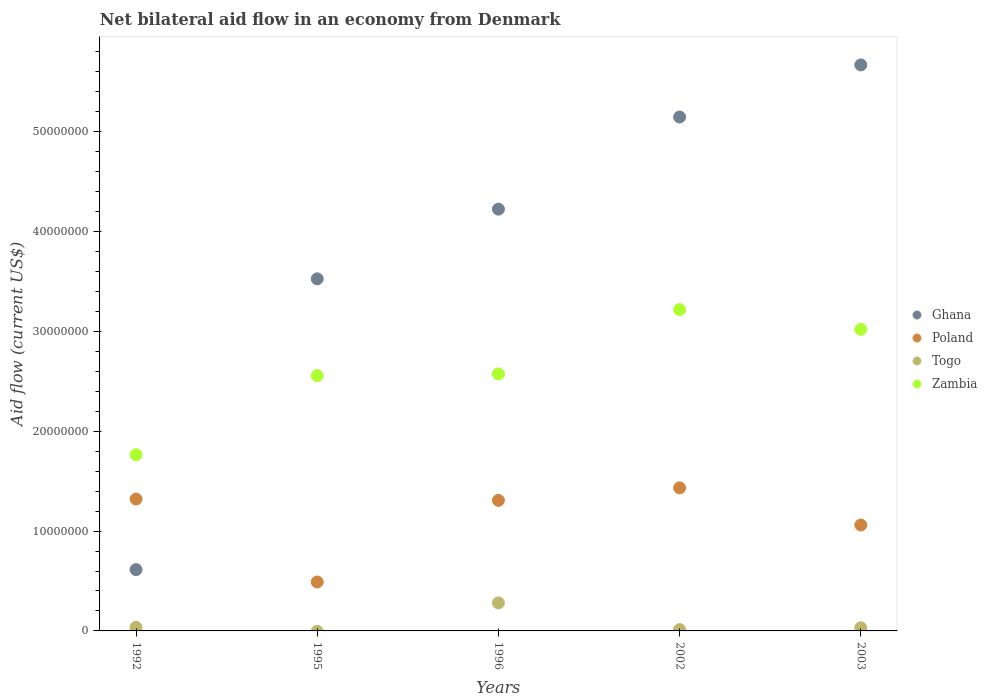What is the net bilateral aid flow in Poland in 2002?
Your answer should be very brief. 1.43e+07. Across all years, what is the maximum net bilateral aid flow in Ghana?
Offer a very short reply. 5.67e+07. Across all years, what is the minimum net bilateral aid flow in Ghana?
Your answer should be compact. 6.14e+06. In which year was the net bilateral aid flow in Zambia maximum?
Ensure brevity in your answer.  2002. What is the total net bilateral aid flow in Togo in the graph?
Offer a terse response. 3.62e+06. What is the difference between the net bilateral aid flow in Poland in 1995 and that in 2002?
Give a very brief answer. -9.43e+06. What is the difference between the net bilateral aid flow in Zambia in 2003 and the net bilateral aid flow in Poland in 1995?
Provide a short and direct response. 2.53e+07. What is the average net bilateral aid flow in Zambia per year?
Offer a terse response. 2.63e+07. In the year 1996, what is the difference between the net bilateral aid flow in Ghana and net bilateral aid flow in Togo?
Your answer should be very brief. 3.94e+07. In how many years, is the net bilateral aid flow in Zambia greater than 40000000 US$?
Make the answer very short. 0. What is the ratio of the net bilateral aid flow in Zambia in 2002 to that in 2003?
Give a very brief answer. 1.07. Is the difference between the net bilateral aid flow in Ghana in 2002 and 2003 greater than the difference between the net bilateral aid flow in Togo in 2002 and 2003?
Keep it short and to the point. No. What is the difference between the highest and the second highest net bilateral aid flow in Ghana?
Your answer should be very brief. 5.22e+06. What is the difference between the highest and the lowest net bilateral aid flow in Togo?
Make the answer very short. 2.81e+06. In how many years, is the net bilateral aid flow in Ghana greater than the average net bilateral aid flow in Ghana taken over all years?
Offer a terse response. 3. Is the sum of the net bilateral aid flow in Poland in 1995 and 2002 greater than the maximum net bilateral aid flow in Togo across all years?
Offer a very short reply. Yes. Is it the case that in every year, the sum of the net bilateral aid flow in Zambia and net bilateral aid flow in Ghana  is greater than the sum of net bilateral aid flow in Togo and net bilateral aid flow in Poland?
Keep it short and to the point. Yes. Is it the case that in every year, the sum of the net bilateral aid flow in Togo and net bilateral aid flow in Poland  is greater than the net bilateral aid flow in Zambia?
Offer a terse response. No. Is the net bilateral aid flow in Togo strictly greater than the net bilateral aid flow in Zambia over the years?
Provide a short and direct response. No. How many dotlines are there?
Your answer should be compact. 4. Are the values on the major ticks of Y-axis written in scientific E-notation?
Ensure brevity in your answer.  No. Does the graph contain any zero values?
Keep it short and to the point. Yes. Where does the legend appear in the graph?
Your answer should be compact. Center right. What is the title of the graph?
Offer a terse response. Net bilateral aid flow in an economy from Denmark. What is the label or title of the X-axis?
Your answer should be compact. Years. What is the Aid flow (current US$) of Ghana in 1992?
Your response must be concise. 6.14e+06. What is the Aid flow (current US$) of Poland in 1992?
Your answer should be very brief. 1.32e+07. What is the Aid flow (current US$) in Zambia in 1992?
Make the answer very short. 1.76e+07. What is the Aid flow (current US$) in Ghana in 1995?
Provide a short and direct response. 3.53e+07. What is the Aid flow (current US$) in Poland in 1995?
Ensure brevity in your answer.  4.90e+06. What is the Aid flow (current US$) in Zambia in 1995?
Provide a succinct answer. 2.56e+07. What is the Aid flow (current US$) of Ghana in 1996?
Give a very brief answer. 4.22e+07. What is the Aid flow (current US$) of Poland in 1996?
Ensure brevity in your answer.  1.31e+07. What is the Aid flow (current US$) of Togo in 1996?
Your answer should be very brief. 2.81e+06. What is the Aid flow (current US$) of Zambia in 1996?
Make the answer very short. 2.58e+07. What is the Aid flow (current US$) in Ghana in 2002?
Ensure brevity in your answer.  5.15e+07. What is the Aid flow (current US$) of Poland in 2002?
Offer a terse response. 1.43e+07. What is the Aid flow (current US$) of Togo in 2002?
Offer a terse response. 1.30e+05. What is the Aid flow (current US$) of Zambia in 2002?
Provide a succinct answer. 3.22e+07. What is the Aid flow (current US$) in Ghana in 2003?
Offer a terse response. 5.67e+07. What is the Aid flow (current US$) in Poland in 2003?
Keep it short and to the point. 1.06e+07. What is the Aid flow (current US$) in Zambia in 2003?
Keep it short and to the point. 3.02e+07. Across all years, what is the maximum Aid flow (current US$) of Ghana?
Give a very brief answer. 5.67e+07. Across all years, what is the maximum Aid flow (current US$) of Poland?
Provide a succinct answer. 1.43e+07. Across all years, what is the maximum Aid flow (current US$) of Togo?
Offer a terse response. 2.81e+06. Across all years, what is the maximum Aid flow (current US$) of Zambia?
Offer a terse response. 3.22e+07. Across all years, what is the minimum Aid flow (current US$) in Ghana?
Your response must be concise. 6.14e+06. Across all years, what is the minimum Aid flow (current US$) of Poland?
Provide a short and direct response. 4.90e+06. Across all years, what is the minimum Aid flow (current US$) of Togo?
Offer a very short reply. 0. Across all years, what is the minimum Aid flow (current US$) of Zambia?
Provide a short and direct response. 1.76e+07. What is the total Aid flow (current US$) in Ghana in the graph?
Your answer should be very brief. 1.92e+08. What is the total Aid flow (current US$) in Poland in the graph?
Your answer should be very brief. 5.61e+07. What is the total Aid flow (current US$) of Togo in the graph?
Give a very brief answer. 3.62e+06. What is the total Aid flow (current US$) in Zambia in the graph?
Keep it short and to the point. 1.31e+08. What is the difference between the Aid flow (current US$) in Ghana in 1992 and that in 1995?
Provide a succinct answer. -2.91e+07. What is the difference between the Aid flow (current US$) in Poland in 1992 and that in 1995?
Offer a terse response. 8.31e+06. What is the difference between the Aid flow (current US$) of Zambia in 1992 and that in 1995?
Provide a short and direct response. -7.93e+06. What is the difference between the Aid flow (current US$) in Ghana in 1992 and that in 1996?
Offer a terse response. -3.61e+07. What is the difference between the Aid flow (current US$) in Togo in 1992 and that in 1996?
Provide a succinct answer. -2.45e+06. What is the difference between the Aid flow (current US$) in Zambia in 1992 and that in 1996?
Your response must be concise. -8.10e+06. What is the difference between the Aid flow (current US$) of Ghana in 1992 and that in 2002?
Your response must be concise. -4.53e+07. What is the difference between the Aid flow (current US$) of Poland in 1992 and that in 2002?
Provide a short and direct response. -1.12e+06. What is the difference between the Aid flow (current US$) in Togo in 1992 and that in 2002?
Provide a short and direct response. 2.30e+05. What is the difference between the Aid flow (current US$) of Zambia in 1992 and that in 2002?
Keep it short and to the point. -1.45e+07. What is the difference between the Aid flow (current US$) of Ghana in 1992 and that in 2003?
Offer a very short reply. -5.06e+07. What is the difference between the Aid flow (current US$) of Poland in 1992 and that in 2003?
Your answer should be very brief. 2.60e+06. What is the difference between the Aid flow (current US$) of Togo in 1992 and that in 2003?
Provide a short and direct response. 4.00e+04. What is the difference between the Aid flow (current US$) of Zambia in 1992 and that in 2003?
Your response must be concise. -1.26e+07. What is the difference between the Aid flow (current US$) in Ghana in 1995 and that in 1996?
Offer a very short reply. -6.98e+06. What is the difference between the Aid flow (current US$) in Poland in 1995 and that in 1996?
Ensure brevity in your answer.  -8.18e+06. What is the difference between the Aid flow (current US$) of Zambia in 1995 and that in 1996?
Offer a very short reply. -1.70e+05. What is the difference between the Aid flow (current US$) in Ghana in 1995 and that in 2002?
Make the answer very short. -1.62e+07. What is the difference between the Aid flow (current US$) of Poland in 1995 and that in 2002?
Make the answer very short. -9.43e+06. What is the difference between the Aid flow (current US$) in Zambia in 1995 and that in 2002?
Keep it short and to the point. -6.61e+06. What is the difference between the Aid flow (current US$) in Ghana in 1995 and that in 2003?
Your answer should be very brief. -2.14e+07. What is the difference between the Aid flow (current US$) in Poland in 1995 and that in 2003?
Ensure brevity in your answer.  -5.71e+06. What is the difference between the Aid flow (current US$) in Zambia in 1995 and that in 2003?
Provide a short and direct response. -4.63e+06. What is the difference between the Aid flow (current US$) of Ghana in 1996 and that in 2002?
Give a very brief answer. -9.23e+06. What is the difference between the Aid flow (current US$) of Poland in 1996 and that in 2002?
Keep it short and to the point. -1.25e+06. What is the difference between the Aid flow (current US$) of Togo in 1996 and that in 2002?
Your response must be concise. 2.68e+06. What is the difference between the Aid flow (current US$) of Zambia in 1996 and that in 2002?
Offer a terse response. -6.44e+06. What is the difference between the Aid flow (current US$) of Ghana in 1996 and that in 2003?
Keep it short and to the point. -1.44e+07. What is the difference between the Aid flow (current US$) of Poland in 1996 and that in 2003?
Provide a short and direct response. 2.47e+06. What is the difference between the Aid flow (current US$) of Togo in 1996 and that in 2003?
Provide a short and direct response. 2.49e+06. What is the difference between the Aid flow (current US$) in Zambia in 1996 and that in 2003?
Your answer should be compact. -4.46e+06. What is the difference between the Aid flow (current US$) in Ghana in 2002 and that in 2003?
Provide a succinct answer. -5.22e+06. What is the difference between the Aid flow (current US$) in Poland in 2002 and that in 2003?
Keep it short and to the point. 3.72e+06. What is the difference between the Aid flow (current US$) in Zambia in 2002 and that in 2003?
Keep it short and to the point. 1.98e+06. What is the difference between the Aid flow (current US$) of Ghana in 1992 and the Aid flow (current US$) of Poland in 1995?
Provide a succinct answer. 1.24e+06. What is the difference between the Aid flow (current US$) of Ghana in 1992 and the Aid flow (current US$) of Zambia in 1995?
Your answer should be very brief. -1.94e+07. What is the difference between the Aid flow (current US$) of Poland in 1992 and the Aid flow (current US$) of Zambia in 1995?
Offer a very short reply. -1.24e+07. What is the difference between the Aid flow (current US$) in Togo in 1992 and the Aid flow (current US$) in Zambia in 1995?
Make the answer very short. -2.52e+07. What is the difference between the Aid flow (current US$) of Ghana in 1992 and the Aid flow (current US$) of Poland in 1996?
Offer a terse response. -6.94e+06. What is the difference between the Aid flow (current US$) in Ghana in 1992 and the Aid flow (current US$) in Togo in 1996?
Give a very brief answer. 3.33e+06. What is the difference between the Aid flow (current US$) of Ghana in 1992 and the Aid flow (current US$) of Zambia in 1996?
Ensure brevity in your answer.  -1.96e+07. What is the difference between the Aid flow (current US$) of Poland in 1992 and the Aid flow (current US$) of Togo in 1996?
Offer a terse response. 1.04e+07. What is the difference between the Aid flow (current US$) of Poland in 1992 and the Aid flow (current US$) of Zambia in 1996?
Give a very brief answer. -1.25e+07. What is the difference between the Aid flow (current US$) of Togo in 1992 and the Aid flow (current US$) of Zambia in 1996?
Provide a succinct answer. -2.54e+07. What is the difference between the Aid flow (current US$) in Ghana in 1992 and the Aid flow (current US$) in Poland in 2002?
Ensure brevity in your answer.  -8.19e+06. What is the difference between the Aid flow (current US$) in Ghana in 1992 and the Aid flow (current US$) in Togo in 2002?
Give a very brief answer. 6.01e+06. What is the difference between the Aid flow (current US$) of Ghana in 1992 and the Aid flow (current US$) of Zambia in 2002?
Offer a terse response. -2.60e+07. What is the difference between the Aid flow (current US$) in Poland in 1992 and the Aid flow (current US$) in Togo in 2002?
Offer a terse response. 1.31e+07. What is the difference between the Aid flow (current US$) of Poland in 1992 and the Aid flow (current US$) of Zambia in 2002?
Provide a succinct answer. -1.90e+07. What is the difference between the Aid flow (current US$) of Togo in 1992 and the Aid flow (current US$) of Zambia in 2002?
Offer a terse response. -3.18e+07. What is the difference between the Aid flow (current US$) in Ghana in 1992 and the Aid flow (current US$) in Poland in 2003?
Offer a very short reply. -4.47e+06. What is the difference between the Aid flow (current US$) of Ghana in 1992 and the Aid flow (current US$) of Togo in 2003?
Your answer should be compact. 5.82e+06. What is the difference between the Aid flow (current US$) of Ghana in 1992 and the Aid flow (current US$) of Zambia in 2003?
Your response must be concise. -2.41e+07. What is the difference between the Aid flow (current US$) in Poland in 1992 and the Aid flow (current US$) in Togo in 2003?
Ensure brevity in your answer.  1.29e+07. What is the difference between the Aid flow (current US$) of Poland in 1992 and the Aid flow (current US$) of Zambia in 2003?
Give a very brief answer. -1.70e+07. What is the difference between the Aid flow (current US$) in Togo in 1992 and the Aid flow (current US$) in Zambia in 2003?
Your answer should be compact. -2.98e+07. What is the difference between the Aid flow (current US$) of Ghana in 1995 and the Aid flow (current US$) of Poland in 1996?
Keep it short and to the point. 2.22e+07. What is the difference between the Aid flow (current US$) in Ghana in 1995 and the Aid flow (current US$) in Togo in 1996?
Your response must be concise. 3.25e+07. What is the difference between the Aid flow (current US$) in Ghana in 1995 and the Aid flow (current US$) in Zambia in 1996?
Ensure brevity in your answer.  9.52e+06. What is the difference between the Aid flow (current US$) of Poland in 1995 and the Aid flow (current US$) of Togo in 1996?
Provide a short and direct response. 2.09e+06. What is the difference between the Aid flow (current US$) in Poland in 1995 and the Aid flow (current US$) in Zambia in 1996?
Provide a short and direct response. -2.08e+07. What is the difference between the Aid flow (current US$) of Ghana in 1995 and the Aid flow (current US$) of Poland in 2002?
Ensure brevity in your answer.  2.09e+07. What is the difference between the Aid flow (current US$) in Ghana in 1995 and the Aid flow (current US$) in Togo in 2002?
Keep it short and to the point. 3.51e+07. What is the difference between the Aid flow (current US$) in Ghana in 1995 and the Aid flow (current US$) in Zambia in 2002?
Provide a succinct answer. 3.08e+06. What is the difference between the Aid flow (current US$) of Poland in 1995 and the Aid flow (current US$) of Togo in 2002?
Provide a short and direct response. 4.77e+06. What is the difference between the Aid flow (current US$) of Poland in 1995 and the Aid flow (current US$) of Zambia in 2002?
Provide a succinct answer. -2.73e+07. What is the difference between the Aid flow (current US$) of Ghana in 1995 and the Aid flow (current US$) of Poland in 2003?
Your answer should be compact. 2.47e+07. What is the difference between the Aid flow (current US$) in Ghana in 1995 and the Aid flow (current US$) in Togo in 2003?
Make the answer very short. 3.50e+07. What is the difference between the Aid flow (current US$) in Ghana in 1995 and the Aid flow (current US$) in Zambia in 2003?
Offer a terse response. 5.06e+06. What is the difference between the Aid flow (current US$) in Poland in 1995 and the Aid flow (current US$) in Togo in 2003?
Provide a short and direct response. 4.58e+06. What is the difference between the Aid flow (current US$) of Poland in 1995 and the Aid flow (current US$) of Zambia in 2003?
Your response must be concise. -2.53e+07. What is the difference between the Aid flow (current US$) of Ghana in 1996 and the Aid flow (current US$) of Poland in 2002?
Offer a very short reply. 2.79e+07. What is the difference between the Aid flow (current US$) of Ghana in 1996 and the Aid flow (current US$) of Togo in 2002?
Your response must be concise. 4.21e+07. What is the difference between the Aid flow (current US$) of Ghana in 1996 and the Aid flow (current US$) of Zambia in 2002?
Make the answer very short. 1.01e+07. What is the difference between the Aid flow (current US$) in Poland in 1996 and the Aid flow (current US$) in Togo in 2002?
Give a very brief answer. 1.30e+07. What is the difference between the Aid flow (current US$) of Poland in 1996 and the Aid flow (current US$) of Zambia in 2002?
Your response must be concise. -1.91e+07. What is the difference between the Aid flow (current US$) of Togo in 1996 and the Aid flow (current US$) of Zambia in 2002?
Give a very brief answer. -2.94e+07. What is the difference between the Aid flow (current US$) in Ghana in 1996 and the Aid flow (current US$) in Poland in 2003?
Your response must be concise. 3.16e+07. What is the difference between the Aid flow (current US$) of Ghana in 1996 and the Aid flow (current US$) of Togo in 2003?
Provide a short and direct response. 4.19e+07. What is the difference between the Aid flow (current US$) of Ghana in 1996 and the Aid flow (current US$) of Zambia in 2003?
Your answer should be compact. 1.20e+07. What is the difference between the Aid flow (current US$) of Poland in 1996 and the Aid flow (current US$) of Togo in 2003?
Provide a succinct answer. 1.28e+07. What is the difference between the Aid flow (current US$) of Poland in 1996 and the Aid flow (current US$) of Zambia in 2003?
Provide a succinct answer. -1.71e+07. What is the difference between the Aid flow (current US$) in Togo in 1996 and the Aid flow (current US$) in Zambia in 2003?
Your response must be concise. -2.74e+07. What is the difference between the Aid flow (current US$) of Ghana in 2002 and the Aid flow (current US$) of Poland in 2003?
Your response must be concise. 4.09e+07. What is the difference between the Aid flow (current US$) in Ghana in 2002 and the Aid flow (current US$) in Togo in 2003?
Give a very brief answer. 5.12e+07. What is the difference between the Aid flow (current US$) of Ghana in 2002 and the Aid flow (current US$) of Zambia in 2003?
Offer a terse response. 2.13e+07. What is the difference between the Aid flow (current US$) of Poland in 2002 and the Aid flow (current US$) of Togo in 2003?
Your answer should be very brief. 1.40e+07. What is the difference between the Aid flow (current US$) of Poland in 2002 and the Aid flow (current US$) of Zambia in 2003?
Give a very brief answer. -1.59e+07. What is the difference between the Aid flow (current US$) of Togo in 2002 and the Aid flow (current US$) of Zambia in 2003?
Provide a succinct answer. -3.01e+07. What is the average Aid flow (current US$) of Ghana per year?
Give a very brief answer. 3.84e+07. What is the average Aid flow (current US$) in Poland per year?
Ensure brevity in your answer.  1.12e+07. What is the average Aid flow (current US$) of Togo per year?
Your answer should be compact. 7.24e+05. What is the average Aid flow (current US$) in Zambia per year?
Offer a terse response. 2.63e+07. In the year 1992, what is the difference between the Aid flow (current US$) in Ghana and Aid flow (current US$) in Poland?
Give a very brief answer. -7.07e+06. In the year 1992, what is the difference between the Aid flow (current US$) in Ghana and Aid flow (current US$) in Togo?
Keep it short and to the point. 5.78e+06. In the year 1992, what is the difference between the Aid flow (current US$) in Ghana and Aid flow (current US$) in Zambia?
Your answer should be very brief. -1.15e+07. In the year 1992, what is the difference between the Aid flow (current US$) in Poland and Aid flow (current US$) in Togo?
Provide a short and direct response. 1.28e+07. In the year 1992, what is the difference between the Aid flow (current US$) of Poland and Aid flow (current US$) of Zambia?
Your answer should be compact. -4.44e+06. In the year 1992, what is the difference between the Aid flow (current US$) in Togo and Aid flow (current US$) in Zambia?
Your answer should be very brief. -1.73e+07. In the year 1995, what is the difference between the Aid flow (current US$) of Ghana and Aid flow (current US$) of Poland?
Provide a short and direct response. 3.04e+07. In the year 1995, what is the difference between the Aid flow (current US$) in Ghana and Aid flow (current US$) in Zambia?
Make the answer very short. 9.69e+06. In the year 1995, what is the difference between the Aid flow (current US$) in Poland and Aid flow (current US$) in Zambia?
Your answer should be very brief. -2.07e+07. In the year 1996, what is the difference between the Aid flow (current US$) in Ghana and Aid flow (current US$) in Poland?
Provide a succinct answer. 2.92e+07. In the year 1996, what is the difference between the Aid flow (current US$) of Ghana and Aid flow (current US$) of Togo?
Provide a succinct answer. 3.94e+07. In the year 1996, what is the difference between the Aid flow (current US$) of Ghana and Aid flow (current US$) of Zambia?
Provide a short and direct response. 1.65e+07. In the year 1996, what is the difference between the Aid flow (current US$) of Poland and Aid flow (current US$) of Togo?
Offer a terse response. 1.03e+07. In the year 1996, what is the difference between the Aid flow (current US$) of Poland and Aid flow (current US$) of Zambia?
Offer a terse response. -1.27e+07. In the year 1996, what is the difference between the Aid flow (current US$) in Togo and Aid flow (current US$) in Zambia?
Make the answer very short. -2.29e+07. In the year 2002, what is the difference between the Aid flow (current US$) of Ghana and Aid flow (current US$) of Poland?
Make the answer very short. 3.72e+07. In the year 2002, what is the difference between the Aid flow (current US$) in Ghana and Aid flow (current US$) in Togo?
Provide a succinct answer. 5.14e+07. In the year 2002, what is the difference between the Aid flow (current US$) in Ghana and Aid flow (current US$) in Zambia?
Give a very brief answer. 1.93e+07. In the year 2002, what is the difference between the Aid flow (current US$) in Poland and Aid flow (current US$) in Togo?
Make the answer very short. 1.42e+07. In the year 2002, what is the difference between the Aid flow (current US$) in Poland and Aid flow (current US$) in Zambia?
Offer a terse response. -1.79e+07. In the year 2002, what is the difference between the Aid flow (current US$) of Togo and Aid flow (current US$) of Zambia?
Make the answer very short. -3.21e+07. In the year 2003, what is the difference between the Aid flow (current US$) in Ghana and Aid flow (current US$) in Poland?
Your response must be concise. 4.61e+07. In the year 2003, what is the difference between the Aid flow (current US$) in Ghana and Aid flow (current US$) in Togo?
Your answer should be very brief. 5.64e+07. In the year 2003, what is the difference between the Aid flow (current US$) in Ghana and Aid flow (current US$) in Zambia?
Your answer should be very brief. 2.65e+07. In the year 2003, what is the difference between the Aid flow (current US$) of Poland and Aid flow (current US$) of Togo?
Keep it short and to the point. 1.03e+07. In the year 2003, what is the difference between the Aid flow (current US$) in Poland and Aid flow (current US$) in Zambia?
Your response must be concise. -1.96e+07. In the year 2003, what is the difference between the Aid flow (current US$) of Togo and Aid flow (current US$) of Zambia?
Make the answer very short. -2.99e+07. What is the ratio of the Aid flow (current US$) in Ghana in 1992 to that in 1995?
Offer a terse response. 0.17. What is the ratio of the Aid flow (current US$) of Poland in 1992 to that in 1995?
Offer a terse response. 2.7. What is the ratio of the Aid flow (current US$) of Zambia in 1992 to that in 1995?
Your answer should be very brief. 0.69. What is the ratio of the Aid flow (current US$) of Ghana in 1992 to that in 1996?
Make the answer very short. 0.15. What is the ratio of the Aid flow (current US$) of Poland in 1992 to that in 1996?
Provide a succinct answer. 1.01. What is the ratio of the Aid flow (current US$) of Togo in 1992 to that in 1996?
Your response must be concise. 0.13. What is the ratio of the Aid flow (current US$) of Zambia in 1992 to that in 1996?
Make the answer very short. 0.69. What is the ratio of the Aid flow (current US$) in Ghana in 1992 to that in 2002?
Provide a short and direct response. 0.12. What is the ratio of the Aid flow (current US$) in Poland in 1992 to that in 2002?
Provide a succinct answer. 0.92. What is the ratio of the Aid flow (current US$) of Togo in 1992 to that in 2002?
Provide a succinct answer. 2.77. What is the ratio of the Aid flow (current US$) of Zambia in 1992 to that in 2002?
Make the answer very short. 0.55. What is the ratio of the Aid flow (current US$) in Ghana in 1992 to that in 2003?
Give a very brief answer. 0.11. What is the ratio of the Aid flow (current US$) in Poland in 1992 to that in 2003?
Provide a succinct answer. 1.25. What is the ratio of the Aid flow (current US$) in Zambia in 1992 to that in 2003?
Provide a succinct answer. 0.58. What is the ratio of the Aid flow (current US$) in Ghana in 1995 to that in 1996?
Offer a terse response. 0.83. What is the ratio of the Aid flow (current US$) in Poland in 1995 to that in 1996?
Offer a terse response. 0.37. What is the ratio of the Aid flow (current US$) in Ghana in 1995 to that in 2002?
Ensure brevity in your answer.  0.69. What is the ratio of the Aid flow (current US$) in Poland in 1995 to that in 2002?
Ensure brevity in your answer.  0.34. What is the ratio of the Aid flow (current US$) of Zambia in 1995 to that in 2002?
Keep it short and to the point. 0.79. What is the ratio of the Aid flow (current US$) in Ghana in 1995 to that in 2003?
Offer a very short reply. 0.62. What is the ratio of the Aid flow (current US$) in Poland in 1995 to that in 2003?
Your answer should be compact. 0.46. What is the ratio of the Aid flow (current US$) of Zambia in 1995 to that in 2003?
Offer a very short reply. 0.85. What is the ratio of the Aid flow (current US$) of Ghana in 1996 to that in 2002?
Provide a short and direct response. 0.82. What is the ratio of the Aid flow (current US$) of Poland in 1996 to that in 2002?
Your answer should be compact. 0.91. What is the ratio of the Aid flow (current US$) in Togo in 1996 to that in 2002?
Make the answer very short. 21.62. What is the ratio of the Aid flow (current US$) of Zambia in 1996 to that in 2002?
Give a very brief answer. 0.8. What is the ratio of the Aid flow (current US$) in Ghana in 1996 to that in 2003?
Offer a terse response. 0.75. What is the ratio of the Aid flow (current US$) in Poland in 1996 to that in 2003?
Keep it short and to the point. 1.23. What is the ratio of the Aid flow (current US$) in Togo in 1996 to that in 2003?
Make the answer very short. 8.78. What is the ratio of the Aid flow (current US$) of Zambia in 1996 to that in 2003?
Offer a very short reply. 0.85. What is the ratio of the Aid flow (current US$) in Ghana in 2002 to that in 2003?
Offer a terse response. 0.91. What is the ratio of the Aid flow (current US$) in Poland in 2002 to that in 2003?
Give a very brief answer. 1.35. What is the ratio of the Aid flow (current US$) of Togo in 2002 to that in 2003?
Offer a very short reply. 0.41. What is the ratio of the Aid flow (current US$) in Zambia in 2002 to that in 2003?
Make the answer very short. 1.07. What is the difference between the highest and the second highest Aid flow (current US$) in Ghana?
Your answer should be compact. 5.22e+06. What is the difference between the highest and the second highest Aid flow (current US$) of Poland?
Your answer should be compact. 1.12e+06. What is the difference between the highest and the second highest Aid flow (current US$) in Togo?
Provide a succinct answer. 2.45e+06. What is the difference between the highest and the second highest Aid flow (current US$) in Zambia?
Your answer should be very brief. 1.98e+06. What is the difference between the highest and the lowest Aid flow (current US$) of Ghana?
Provide a succinct answer. 5.06e+07. What is the difference between the highest and the lowest Aid flow (current US$) of Poland?
Your response must be concise. 9.43e+06. What is the difference between the highest and the lowest Aid flow (current US$) of Togo?
Provide a short and direct response. 2.81e+06. What is the difference between the highest and the lowest Aid flow (current US$) in Zambia?
Your response must be concise. 1.45e+07. 